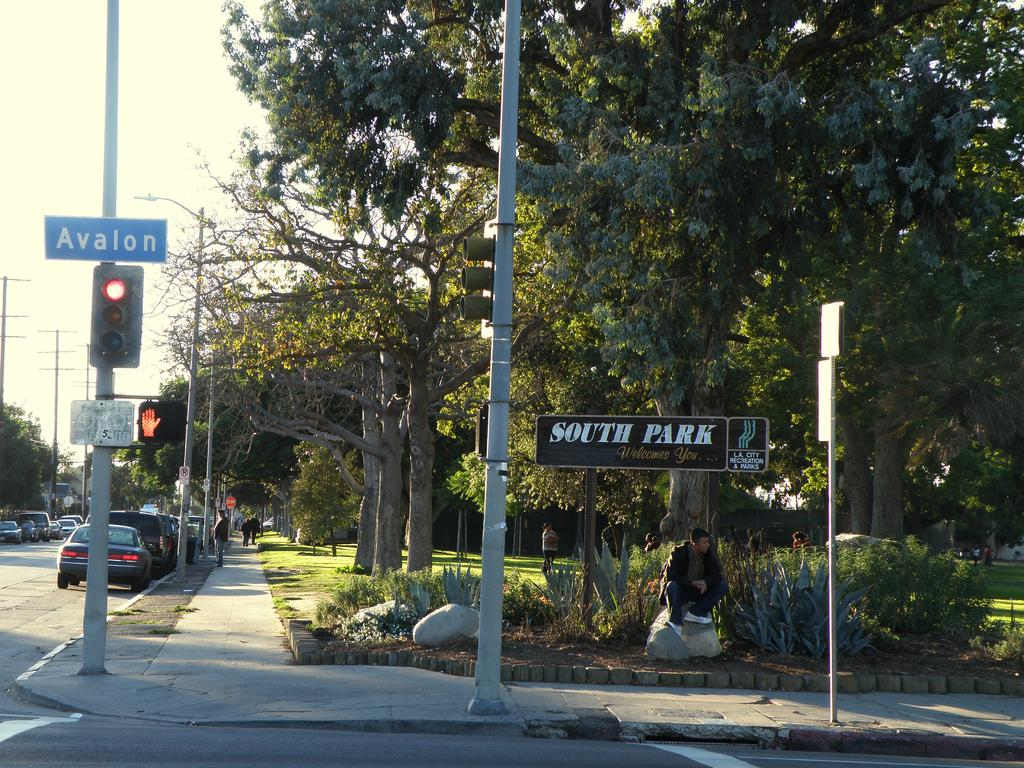<image>
Create a compact narrative representing the image presented. A man is sitting under a sign that welcomes you to South Park. 